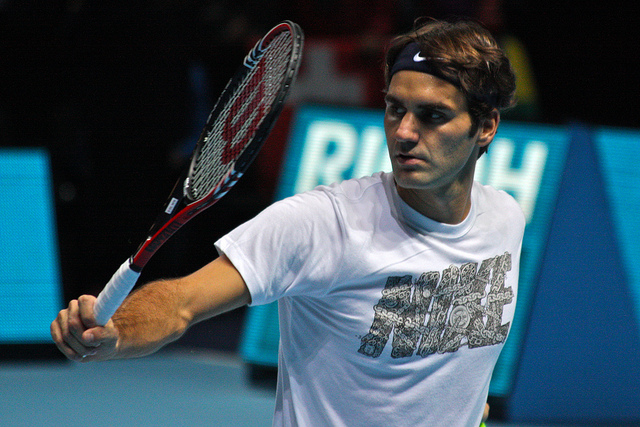Read all the text in this image. W NME 